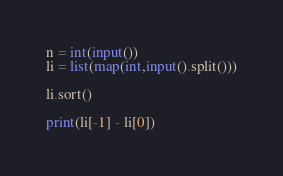<code> <loc_0><loc_0><loc_500><loc_500><_Python_>n = int(input())
li = list(map(int,input().split()))

li.sort()

print(li[-1] - li[0])
</code> 